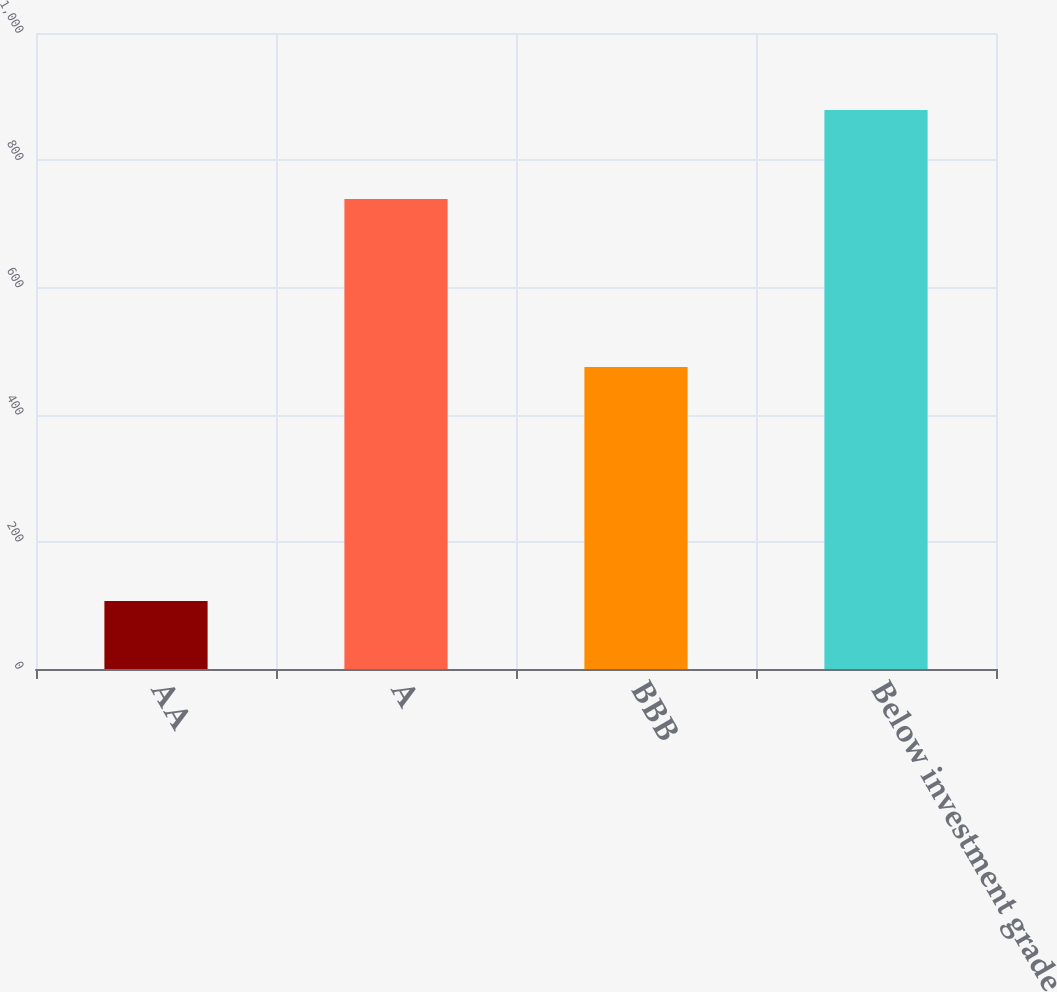Convert chart. <chart><loc_0><loc_0><loc_500><loc_500><bar_chart><fcel>AA<fcel>A<fcel>BBB<fcel>Below investment grade<nl><fcel>107<fcel>739<fcel>475<fcel>879<nl></chart> 